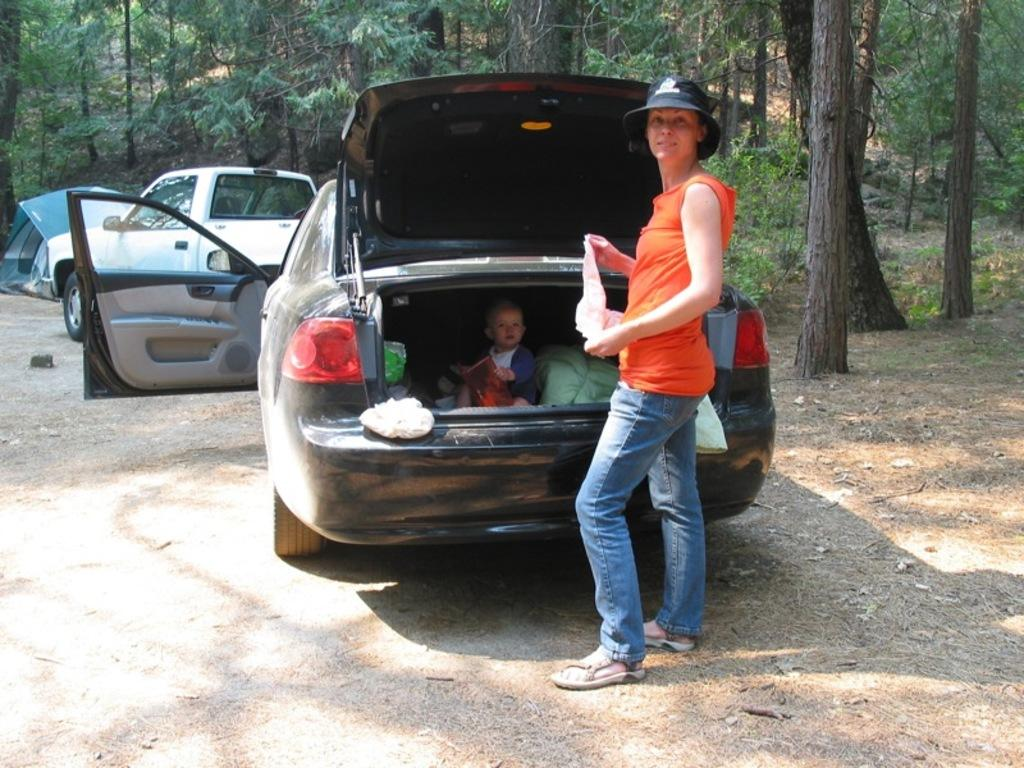What type of vehicle is in the image? There is a mini truck in the image. What other vehicle can be seen in the image? There is a car in the image. Who is present in the image? A woman is standing in the image, and a boy is in the car. What can be seen in the background of the image? There are trees visible in the image. Where is the cave located in the image? There is no cave present in the image. 